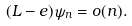Convert formula to latex. <formula><loc_0><loc_0><loc_500><loc_500>( L - e ) \psi _ { n } = o ( n ) .</formula> 